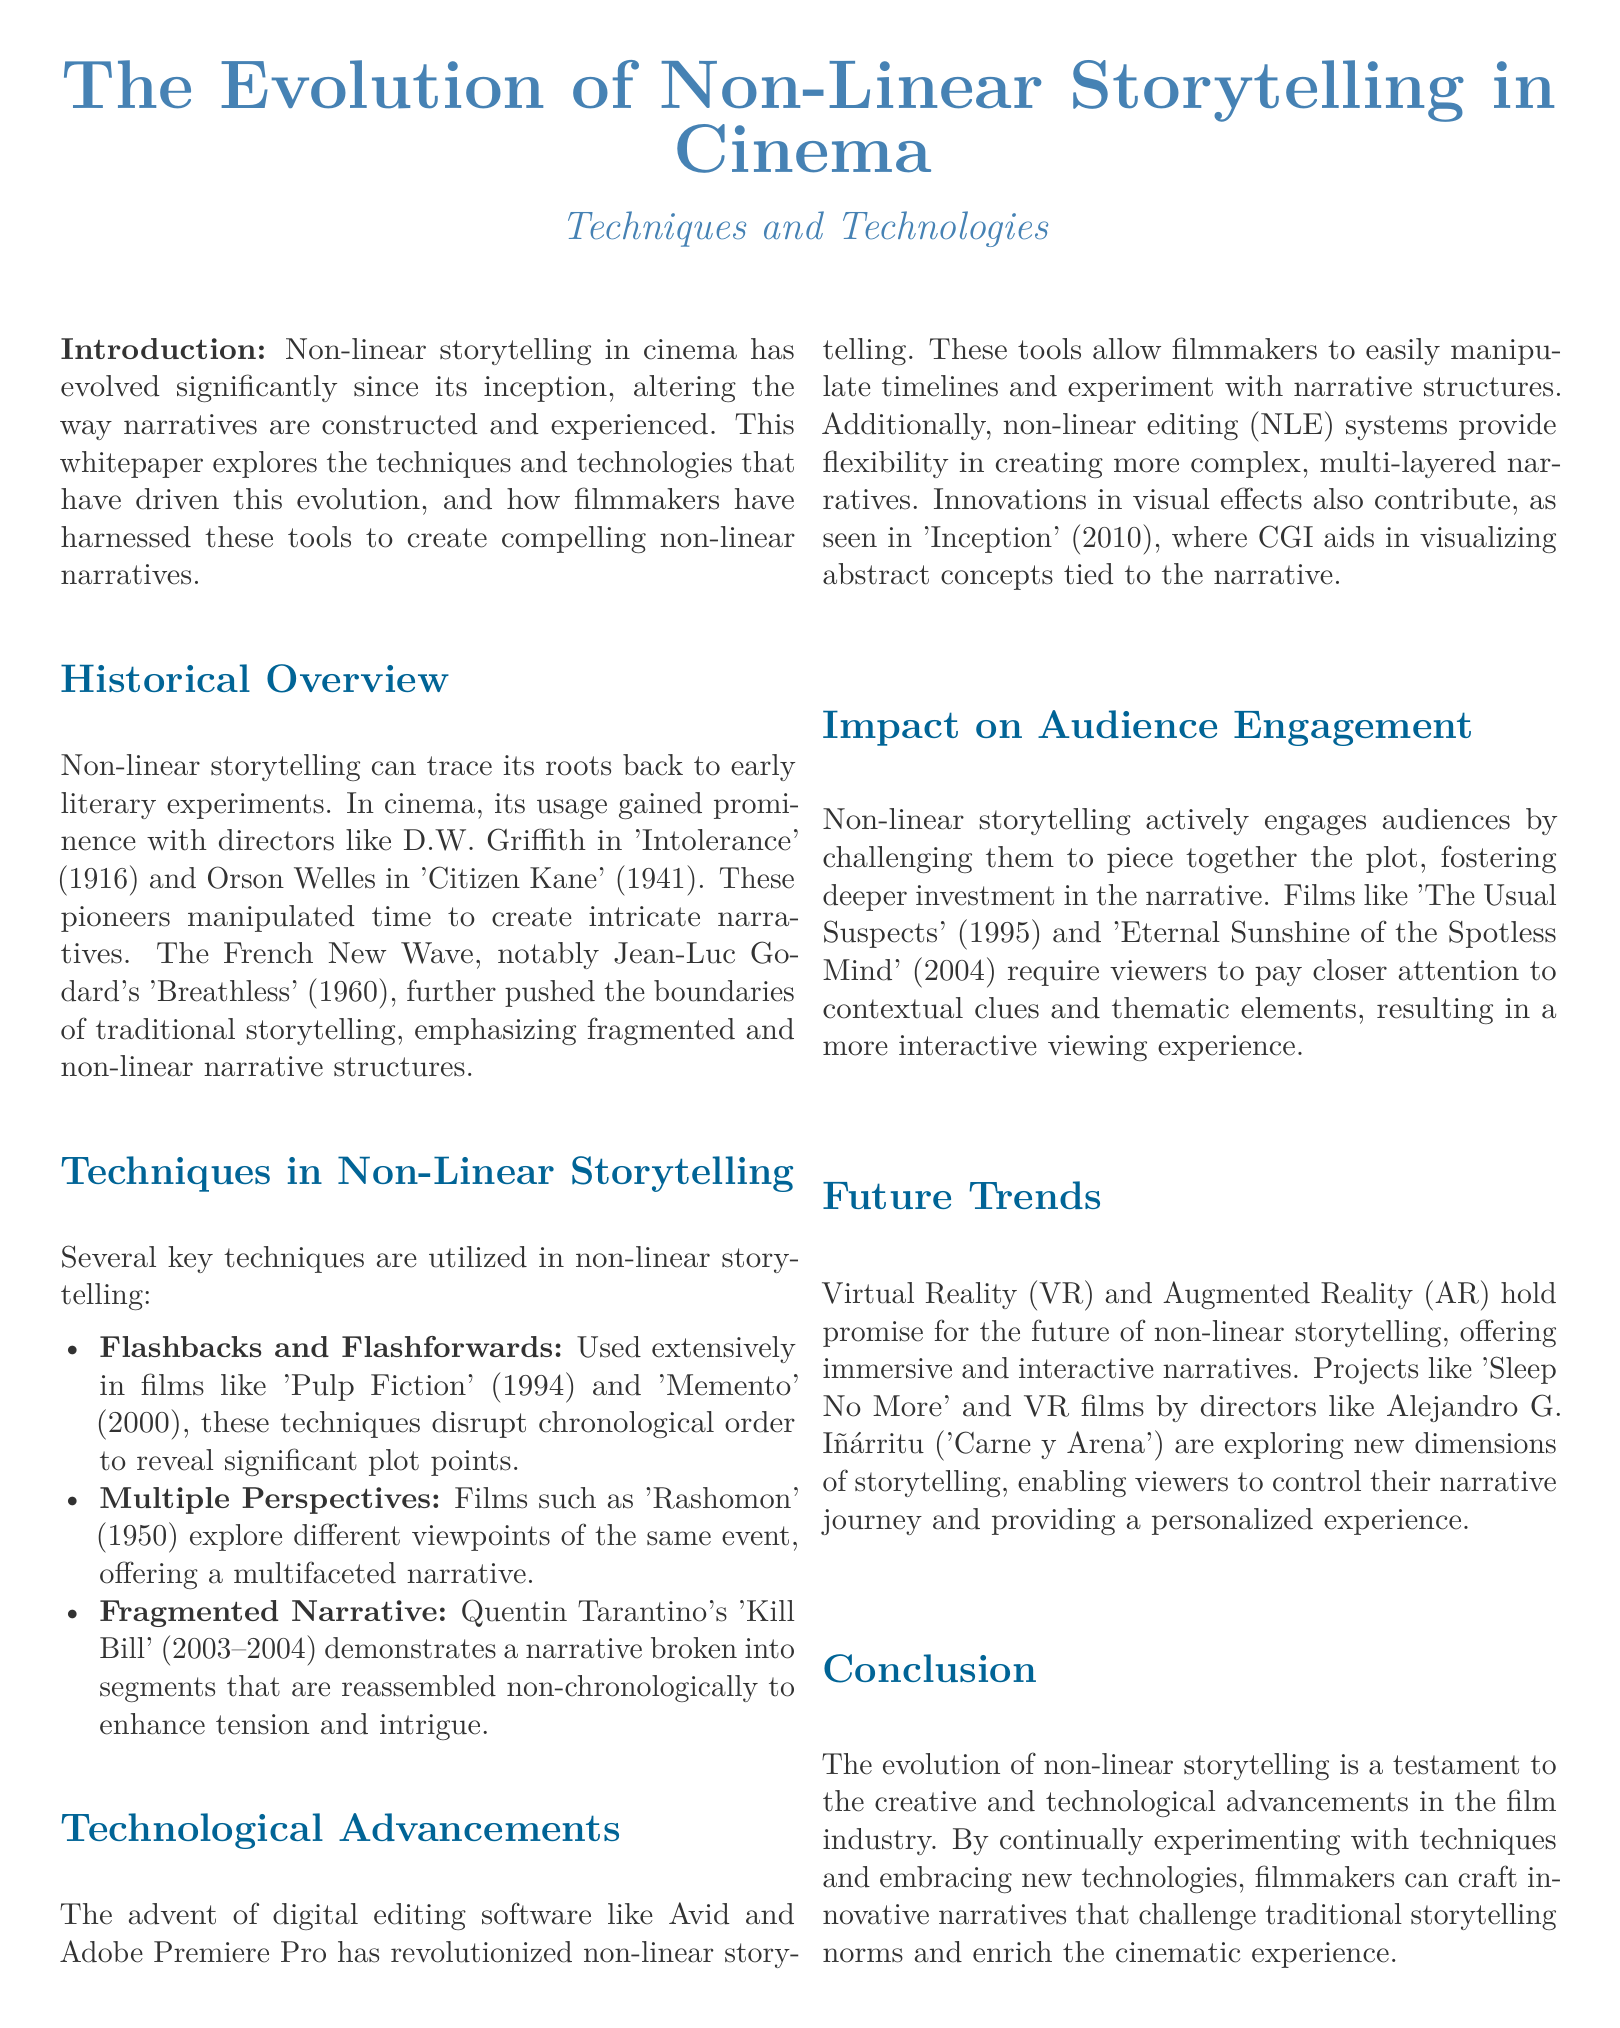What year was 'Intolerance' released? 'Intolerance' was released in 1916 as mentioned in the Historical Overview section.
Answer: 1916 Which technique disrupts chronological order in films? Flashbacks and Flashforwards are techniques that disrupt chronological order.
Answer: Flashbacks and Flashforwards Name a film that uses multiple perspectives. 'Rashomon' explores different viewpoints of the same event and is mentioned in the Techniques section.
Answer: Rashomon What does NLE stand for? NLE stands for non-linear editing system, which is discussed in the Technological Advancements section.
Answer: Non-linear editing Which director is associated with the film 'Inception'? Christopher Nolan directed the film 'Inception', mentioned in the Technological Advancements section.
Answer: Christopher Nolan What is a promising technology for future non-linear storytelling? Virtual Reality is mentioned as a promising technology for future non-linear storytelling in the Future Trends section.
Answer: Virtual Reality How does non-linear storytelling impact audience engagement? Non-linear storytelling engages audiences by challenging them to piece together the plot, noted in the Impact on Audience Engagement section.
Answer: By challenging them to piece together the plot What genre does 'Eternal Sunshine of the Spotless Mind' belong to? While not explicitly stated, it is commonly understood to be a drama/sci-fi film, included in the Impact on Audience Engagement section.
Answer: Drama/Sci-fi What type of document is this? The document is a whitepaper discussing the evolution of non-linear storytelling in cinema.
Answer: Whitepaper 